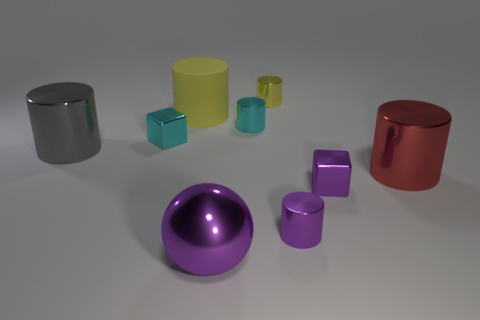What number of yellow objects have the same material as the big sphere?
Make the answer very short. 1. Is the number of large gray shiny objects that are behind the big shiny ball less than the number of tiny cyan metal cylinders in front of the red metallic object?
Provide a short and direct response. No. What is the yellow object that is in front of the shiny object that is behind the yellow object that is to the left of the small yellow metal object made of?
Provide a short and direct response. Rubber. There is a thing that is left of the yellow metal thing and in front of the red cylinder; what size is it?
Provide a succinct answer. Large. How many blocks are either small cyan objects or small brown rubber objects?
Your answer should be compact. 1. What is the color of the rubber cylinder that is the same size as the metal ball?
Your answer should be compact. Yellow. Is there any other thing that is the same shape as the large purple thing?
Provide a succinct answer. No. There is a big matte thing that is the same shape as the yellow metallic object; what color is it?
Make the answer very short. Yellow. What number of objects are either red rubber cylinders or things that are in front of the tiny yellow metallic object?
Ensure brevity in your answer.  8. Are there fewer tiny cyan metal cylinders to the right of the yellow metal cylinder than small brown objects?
Make the answer very short. No. 